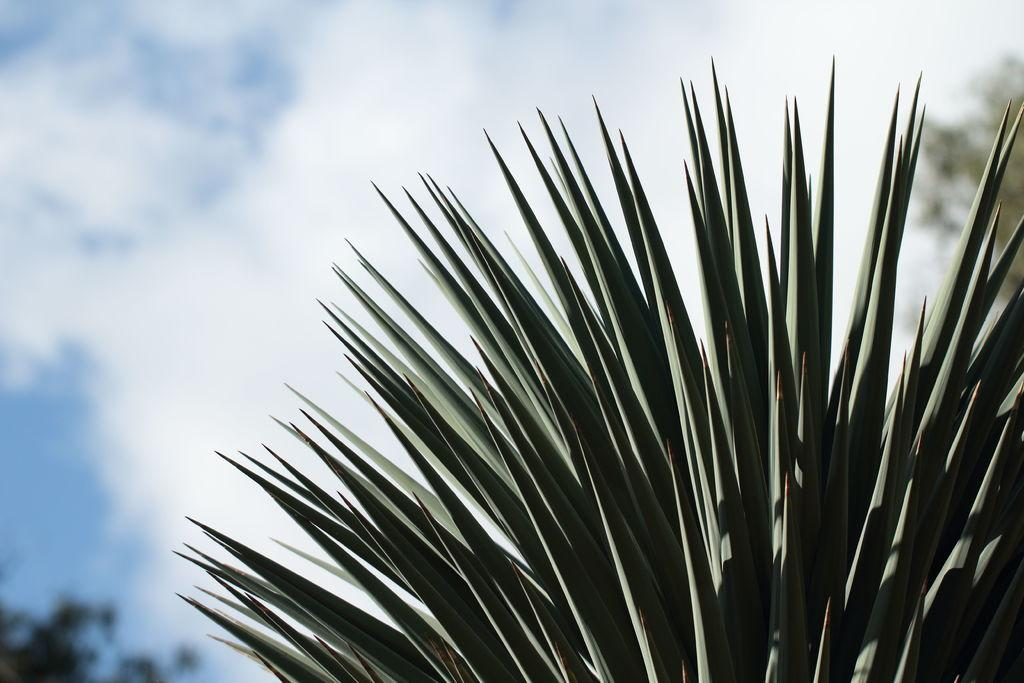What type of vegetation can be seen in the image? There are trees in the image. What can be seen in the sky in the image? There are clouds in the image. What type of oven is visible in the image? There is no oven present in the image. What is the mind of the tree thinking in the image? Trees do not have minds, so it is not possible to determine what they might be thinking. 